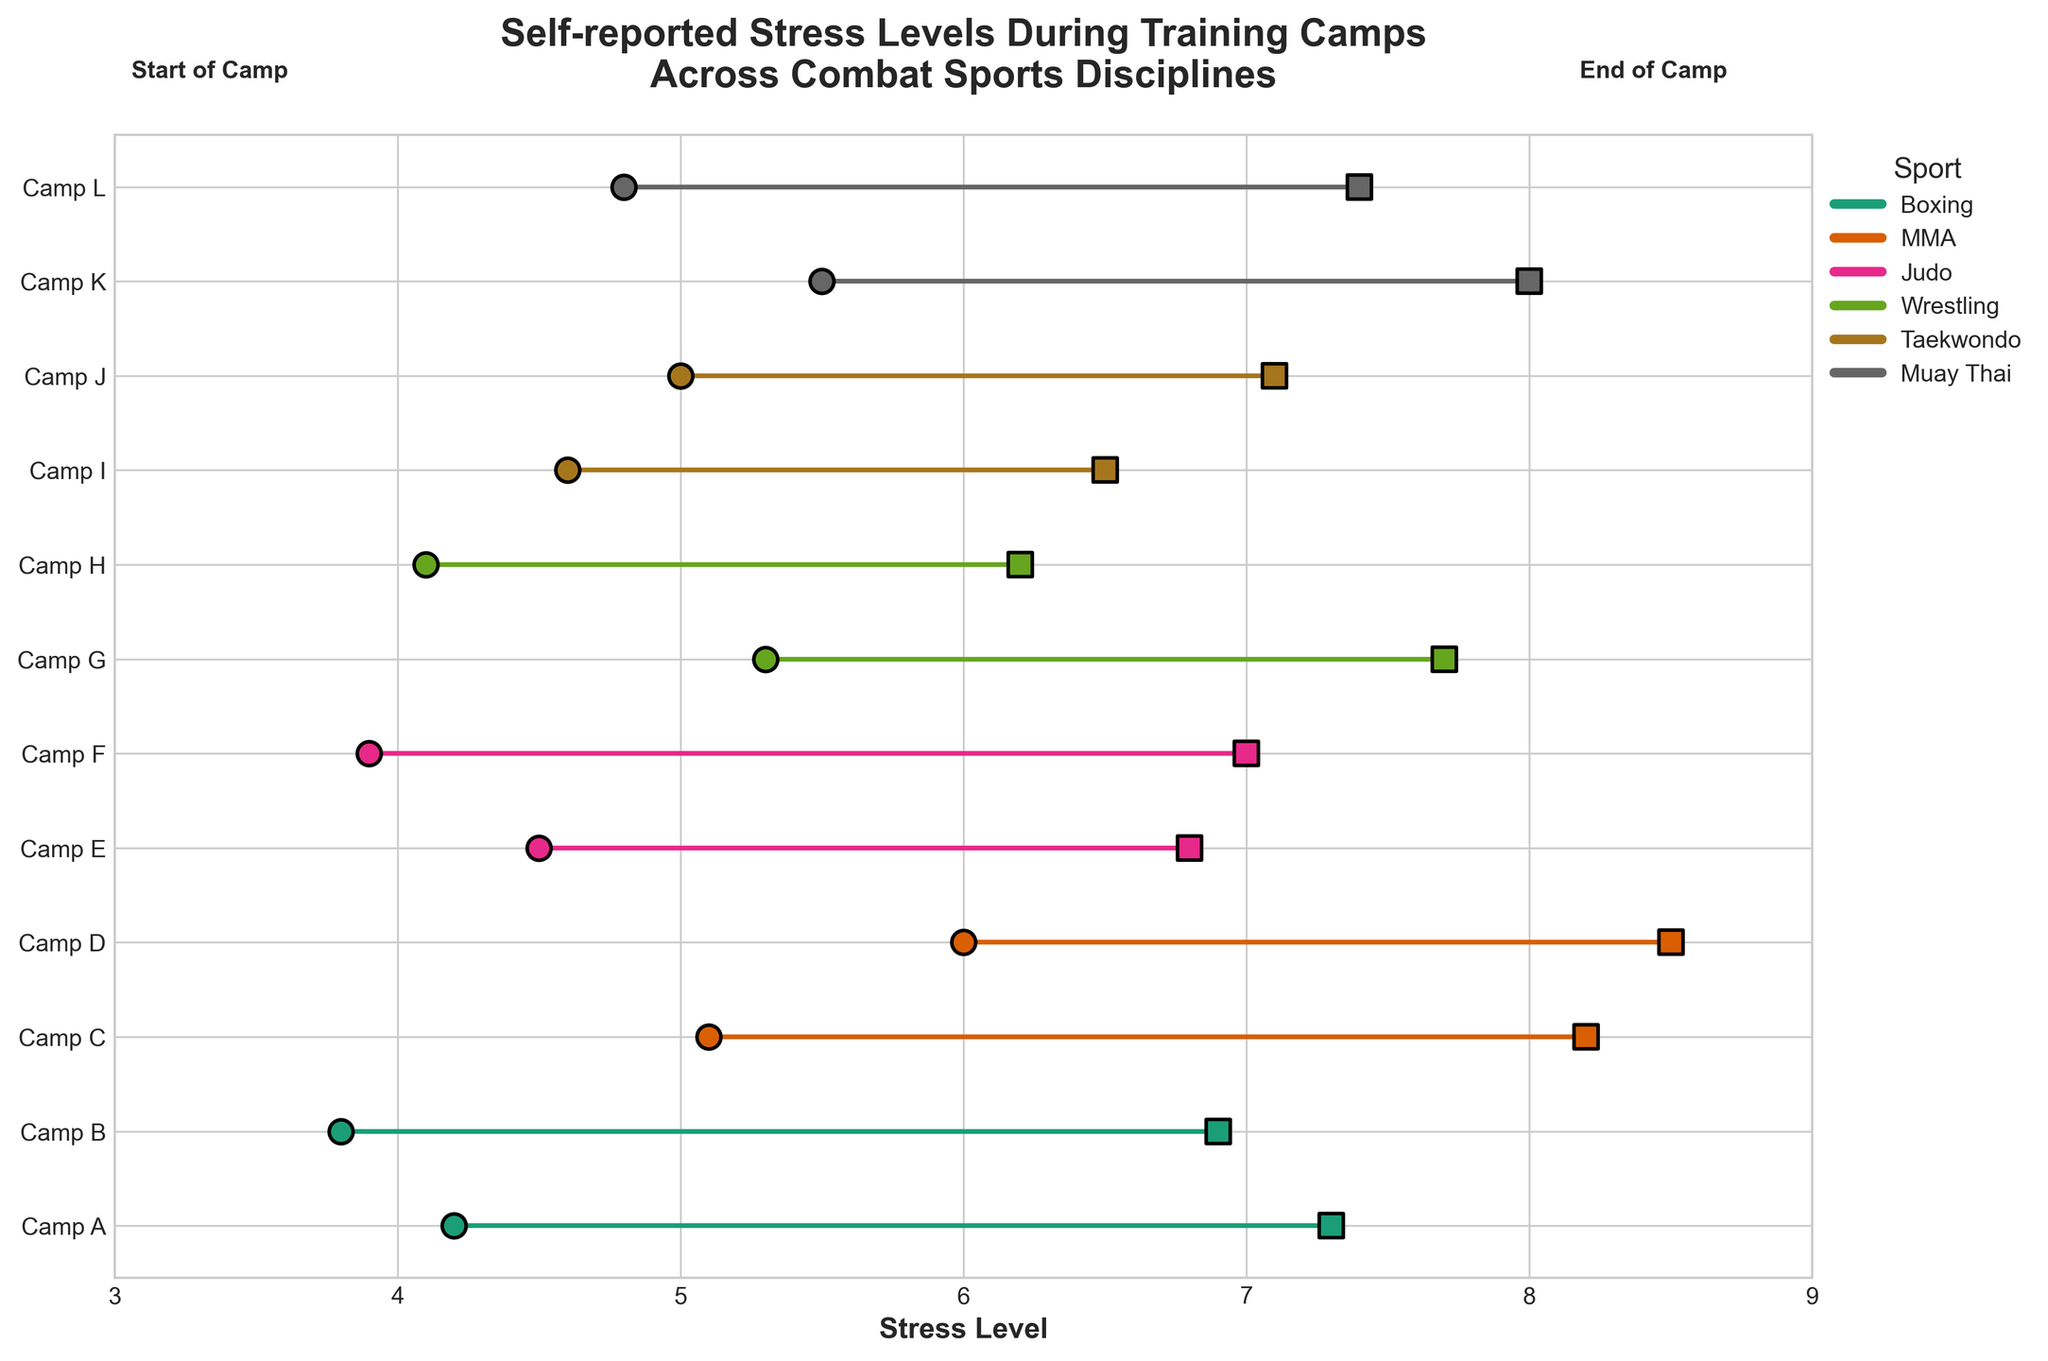What's the range of stress levels at the start of the training camps? To find the range, you need to identify the minimum and the maximum stress levels at the start of the training camps from the figure. The values range from 3.8 to 6.0
Answer: range is 2.2 Which training camp showed the largest increase in stress level? From the figure, you can see the distances between the start and end points for each camp. Camp D (MMA) shows the largest increase in stress level, moving from 6.0 to 8.5, which is an increase of 2.5
Answer: Camp D Which sport has the highest average stress level at the end of the training camps? Calculate the average end stress levels for each sport by visually identifying the values: 
Boxing (7.3+6.9)/2 = 7.1,
MMA (8.2+8.5)/2 = 8.35,
Judo (6.8+7.0)/2 = 6.9,
Wrestling (7.7+6.2)/2 = 6.95,
Taekwondo (6.5+7.1)/2 = 6.8,
Muay Thai (8.0+7.4)/2 = 7.7.
MMA has the highest average stress level at the end of the training camps with an average of 8.35
Answer: MMA What is the overall trend in stress levels from start to end of the training camps? Observing the figure, it’s clear that almost every training camp shows an increase in stress level from the start to the end, indicating an overall upward trend in stress levels through the training period
Answer: upward trend Which sport has the smallest variability in the stress level increase during the training camps? To find this, compare the differences (or variability) between the start and end stress levels for each sport:
Boxing: Camp A (3.1), Camp B (3.1),
MMA: Camp C (3.1), Camp D (2.5),
Judo: Camp E (2.3), Camp F (3.1),
Wrestling: Camp G (2.4), Camp H (2.1),
Taekwondo: Camp I (1.9), Camp J (2.1),
Muay Thai: Camp K (2.5), Camp L (2.6).
Taekwondo has the smallest variability, with increases from 1.9 to 2.1
Answer: Taekwondo 